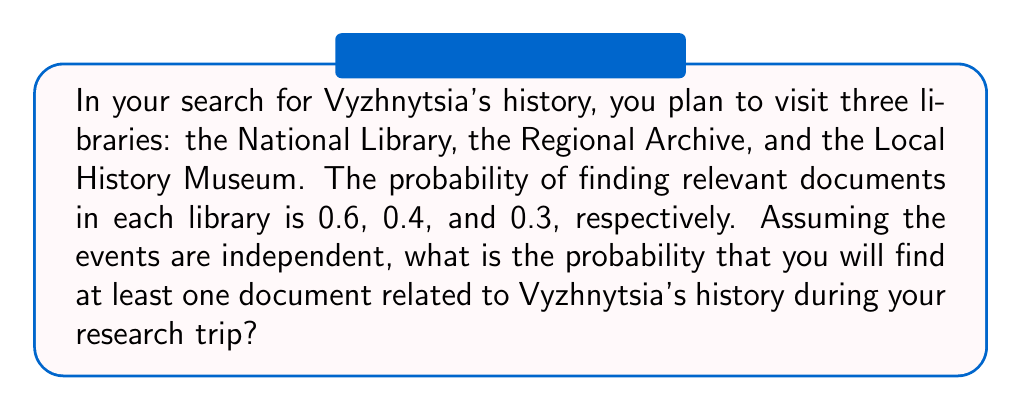Solve this math problem. Let's approach this step-by-step:

1) First, let's define our events:
   A: Finding a document in the National Library (P(A) = 0.6)
   B: Finding a document in the Regional Archive (P(B) = 0.4)
   C: Finding a document in the Local History Museum (P(C) = 0.3)

2) We want to find the probability of finding at least one document, which is easier to calculate by subtracting the probability of finding no documents from 1.

3) The probability of not finding a document in each library:
   P(not A) = 1 - 0.6 = 0.4
   P(not B) = 1 - 0.4 = 0.6
   P(not C) = 1 - 0.3 = 0.7

4) Since the events are independent, the probability of not finding a document in any of the libraries is the product of these probabilities:

   P(no document) = P(not A) × P(not B) × P(not C)
                  = 0.4 × 0.6 × 0.7
                  = 0.168

5) Therefore, the probability of finding at least one document is:

   P(at least one document) = 1 - P(no document)
                             = 1 - 0.168
                             = 0.832

6) We can express this as a percentage: 0.832 × 100% = 83.2%
Answer: 0.832 or 83.2% 